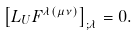Convert formula to latex. <formula><loc_0><loc_0><loc_500><loc_500>\left [ L _ { U } F ^ { \lambda ( \mu \nu ) } \right ] _ { ; \lambda } = 0 .</formula> 